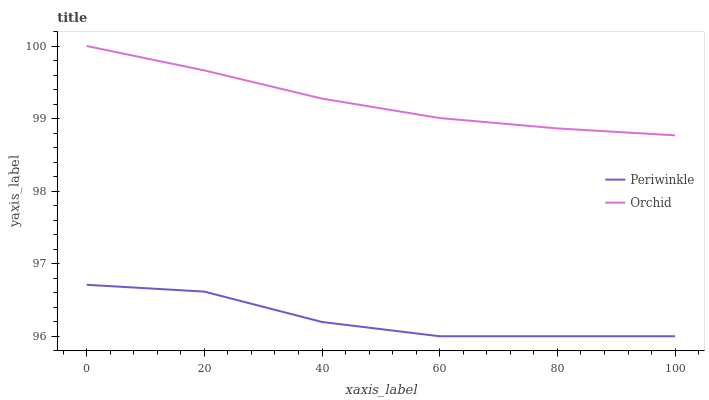Does Periwinkle have the minimum area under the curve?
Answer yes or no. Yes. Does Orchid have the maximum area under the curve?
Answer yes or no. Yes. Does Orchid have the minimum area under the curve?
Answer yes or no. No. Is Orchid the smoothest?
Answer yes or no. Yes. Is Periwinkle the roughest?
Answer yes or no. Yes. Is Orchid the roughest?
Answer yes or no. No. Does Periwinkle have the lowest value?
Answer yes or no. Yes. Does Orchid have the lowest value?
Answer yes or no. No. Does Orchid have the highest value?
Answer yes or no. Yes. Is Periwinkle less than Orchid?
Answer yes or no. Yes. Is Orchid greater than Periwinkle?
Answer yes or no. Yes. Does Periwinkle intersect Orchid?
Answer yes or no. No. 